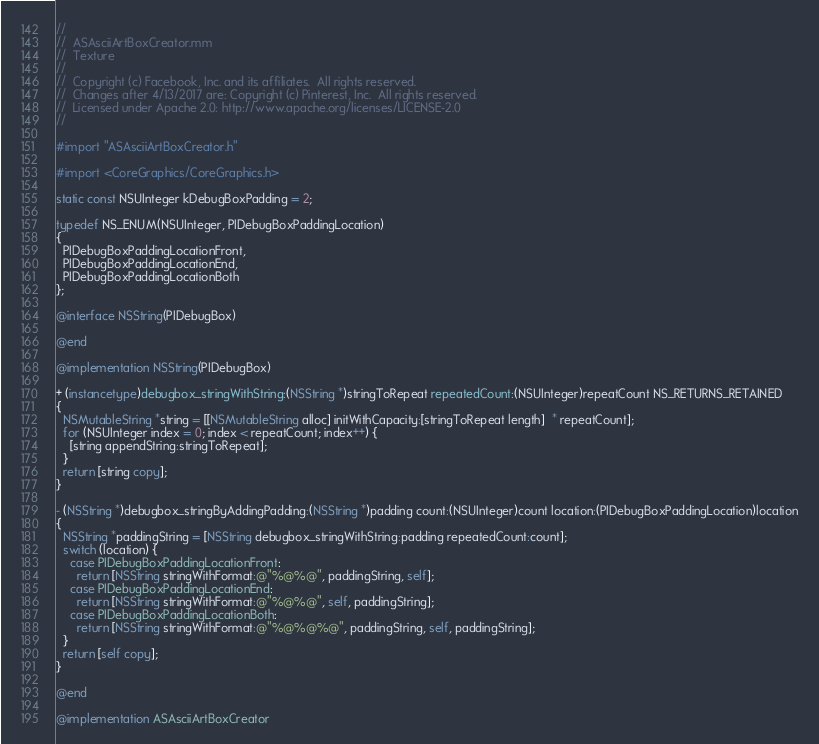<code> <loc_0><loc_0><loc_500><loc_500><_ObjectiveC_>//
//  ASAsciiArtBoxCreator.mm
//  Texture
//
//  Copyright (c) Facebook, Inc. and its affiliates.  All rights reserved.
//  Changes after 4/13/2017 are: Copyright (c) Pinterest, Inc.  All rights reserved.
//  Licensed under Apache 2.0: http://www.apache.org/licenses/LICENSE-2.0
//

#import "ASAsciiArtBoxCreator.h"

#import <CoreGraphics/CoreGraphics.h>

static const NSUInteger kDebugBoxPadding = 2;

typedef NS_ENUM(NSUInteger, PIDebugBoxPaddingLocation)
{
  PIDebugBoxPaddingLocationFront,
  PIDebugBoxPaddingLocationEnd,
  PIDebugBoxPaddingLocationBoth
};

@interface NSString(PIDebugBox)

@end

@implementation NSString(PIDebugBox)

+ (instancetype)debugbox_stringWithString:(NSString *)stringToRepeat repeatedCount:(NSUInteger)repeatCount NS_RETURNS_RETAINED
{
  NSMutableString *string = [[NSMutableString alloc] initWithCapacity:[stringToRepeat length]  * repeatCount];
  for (NSUInteger index = 0; index < repeatCount; index++) {
    [string appendString:stringToRepeat];
  }
  return [string copy];
}

- (NSString *)debugbox_stringByAddingPadding:(NSString *)padding count:(NSUInteger)count location:(PIDebugBoxPaddingLocation)location
{
  NSString *paddingString = [NSString debugbox_stringWithString:padding repeatedCount:count];
  switch (location) {
    case PIDebugBoxPaddingLocationFront:
      return [NSString stringWithFormat:@"%@%@", paddingString, self];
    case PIDebugBoxPaddingLocationEnd:
      return [NSString stringWithFormat:@"%@%@", self, paddingString];
    case PIDebugBoxPaddingLocationBoth:
      return [NSString stringWithFormat:@"%@%@%@", paddingString, self, paddingString];
  }
  return [self copy];
}

@end

@implementation ASAsciiArtBoxCreator
</code> 